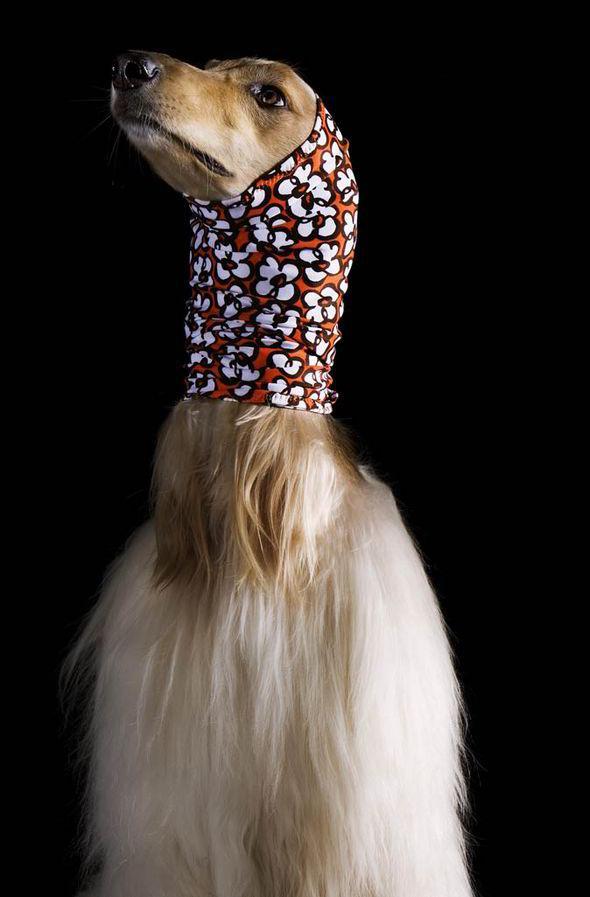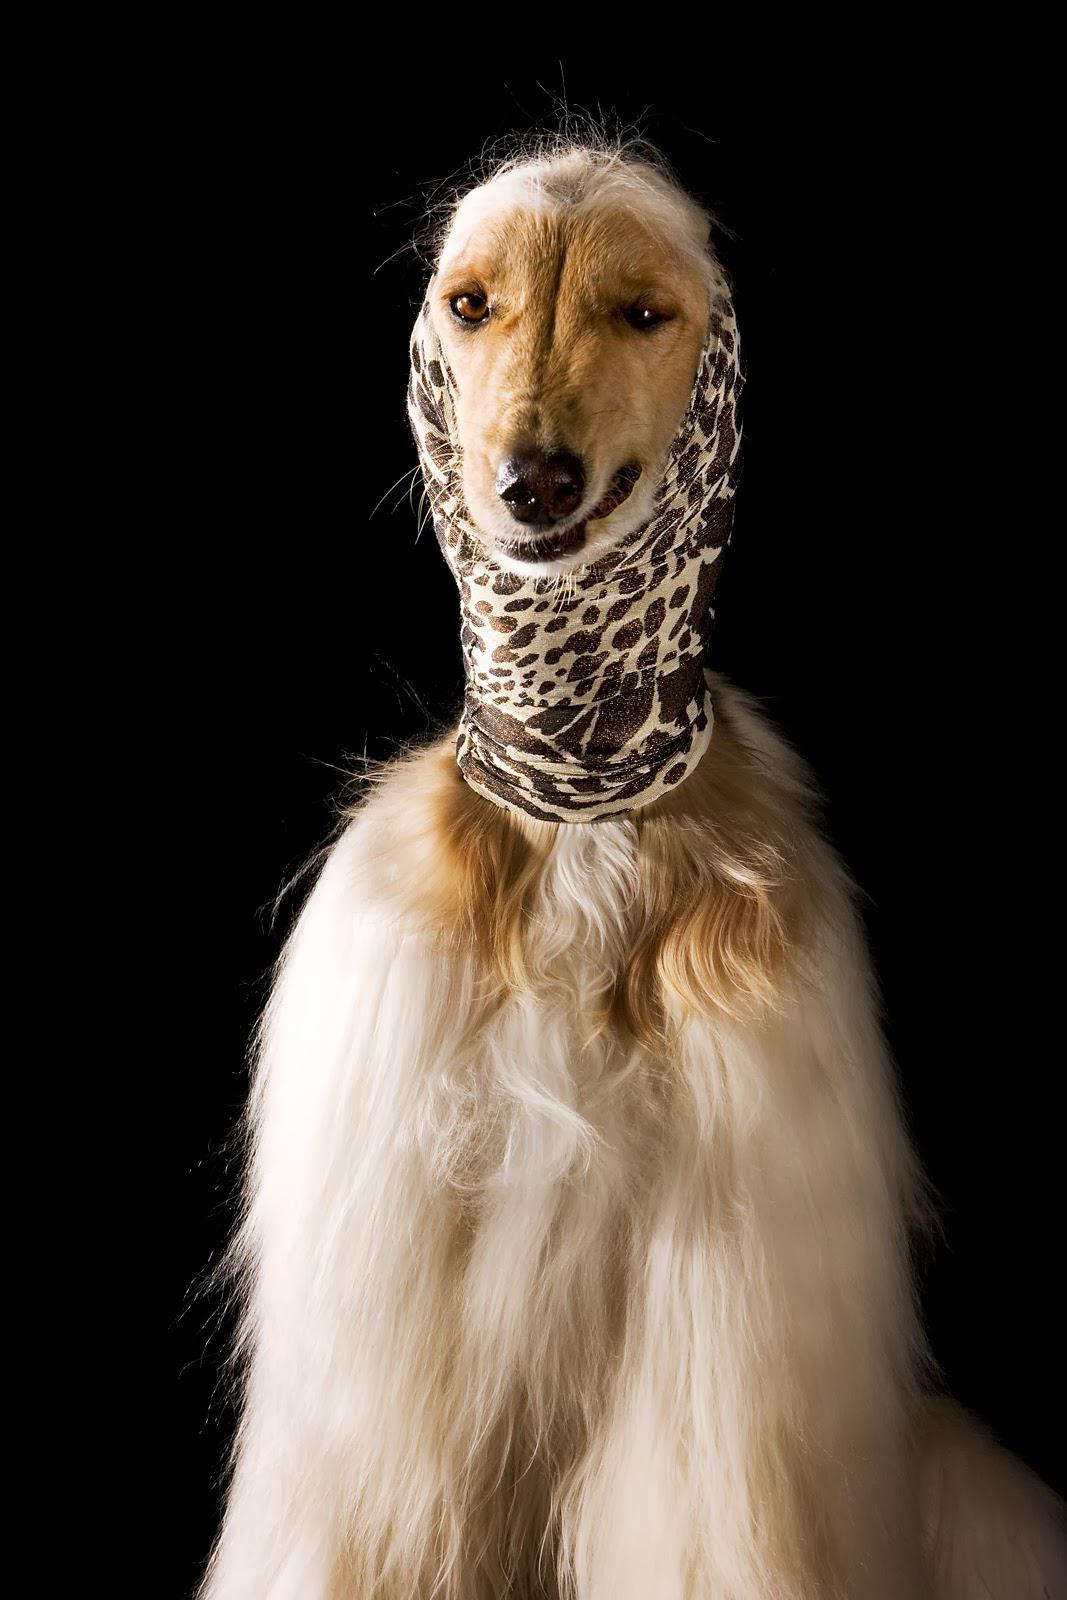The first image is the image on the left, the second image is the image on the right. Analyze the images presented: Is the assertion "Both images feature a dog wearing a head scarf." valid? Answer yes or no. Yes. The first image is the image on the left, the second image is the image on the right. Considering the images on both sides, is "Each image shows an afghan hound wearing a wrap that covers its neck, ears and the top of its head." valid? Answer yes or no. Yes. 